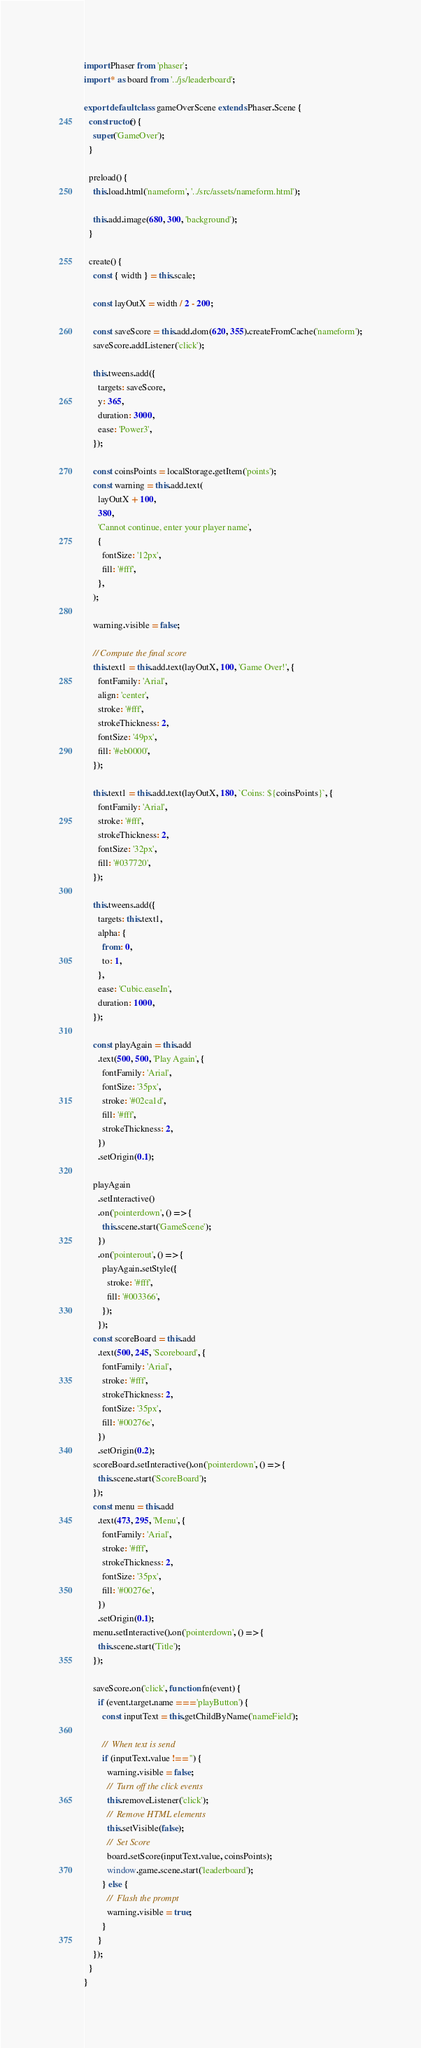Convert code to text. <code><loc_0><loc_0><loc_500><loc_500><_JavaScript_>import Phaser from 'phaser';
import * as board from '../js/leaderboard';

export default class gameOverScene extends Phaser.Scene {
  constructor() {
    super('GameOver');
  }

  preload() {
    this.load.html('nameform', '../src/assets/nameform.html');

    this.add.image(680, 300, 'background');
  }

  create() {
    const { width } = this.scale;

    const layOutX = width / 2 - 200;

    const saveScore = this.add.dom(620, 355).createFromCache('nameform');
    saveScore.addListener('click');

    this.tweens.add({
      targets: saveScore,
      y: 365,
      duration: 3000,
      ease: 'Power3',
    });

    const coinsPoints = localStorage.getItem('points');
    const warning = this.add.text(
      layOutX + 100,
      380,
      'Cannot continue, enter your player name',
      {
        fontSize: '12px',
        fill: '#fff',
      },
    );

    warning.visible = false;

    // Compute the final score
    this.text1 = this.add.text(layOutX, 100, 'Game Over!', {
      fontFamily: 'Arial',
      align: 'center',
      stroke: '#fff',
      strokeThickness: 2,
      fontSize: '49px',
      fill: '#eb0000',
    });

    this.text1 = this.add.text(layOutX, 180, `Coins: ${coinsPoints}`, {
      fontFamily: 'Arial',
      stroke: '#fff',
      strokeThickness: 2,
      fontSize: '32px',
      fill: '#037720',
    });

    this.tweens.add({
      targets: this.text1,
      alpha: {
        from: 0,
        to: 1,
      },
      ease: 'Cubic.easeIn',
      duration: 1000,
    });

    const playAgain = this.add
      .text(500, 500, 'Play Again', {
        fontFamily: 'Arial',
        fontSize: '35px',
        stroke: '#02ca1d',
        fill: '#fff',
        strokeThickness: 2,
      })
      .setOrigin(0.1);

    playAgain
      .setInteractive()
      .on('pointerdown', () => {
        this.scene.start('GameScene');
      })
      .on('pointerout', () => {
        playAgain.setStyle({
          stroke: '#fff',
          fill: '#003366',
        });
      });
    const scoreBoard = this.add
      .text(500, 245, 'Scoreboard', {
        fontFamily: 'Arial',
        stroke: '#fff',
        strokeThickness: 2,
        fontSize: '35px',
        fill: '#00276e',
      })
      .setOrigin(0.2);
    scoreBoard.setInteractive().on('pointerdown', () => {
      this.scene.start('ScoreBoard');
    });
    const menu = this.add
      .text(473, 295, 'Menu', {
        fontFamily: 'Arial',
        stroke: '#fff',
        strokeThickness: 2,
        fontSize: '35px',
        fill: '#00276e',
      })
      .setOrigin(0.1);
    menu.setInteractive().on('pointerdown', () => {
      this.scene.start('Title');
    });

    saveScore.on('click', function fn(event) {
      if (event.target.name === 'playButton') {
        const inputText = this.getChildByName('nameField');

        //  When text is send
        if (inputText.value !== '') {
          warning.visible = false;
          //  Turn off the click events
          this.removeListener('click');
          //  Remove HTML elements
          this.setVisible(false);
          //  Set Score
          board.setScore(inputText.value, coinsPoints);
          window.game.scene.start('leaderboard');
        } else {
          //  Flash the prompt
          warning.visible = true;
        }
      }
    });
  }
}
</code> 